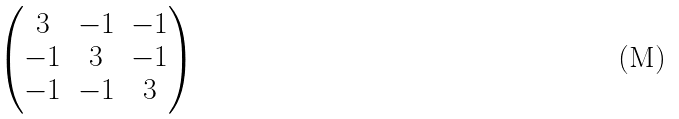<formula> <loc_0><loc_0><loc_500><loc_500>\begin{pmatrix} 3 & - 1 & - 1 \\ - 1 & 3 & - 1 \\ - 1 & - 1 & 3 \end{pmatrix}</formula> 